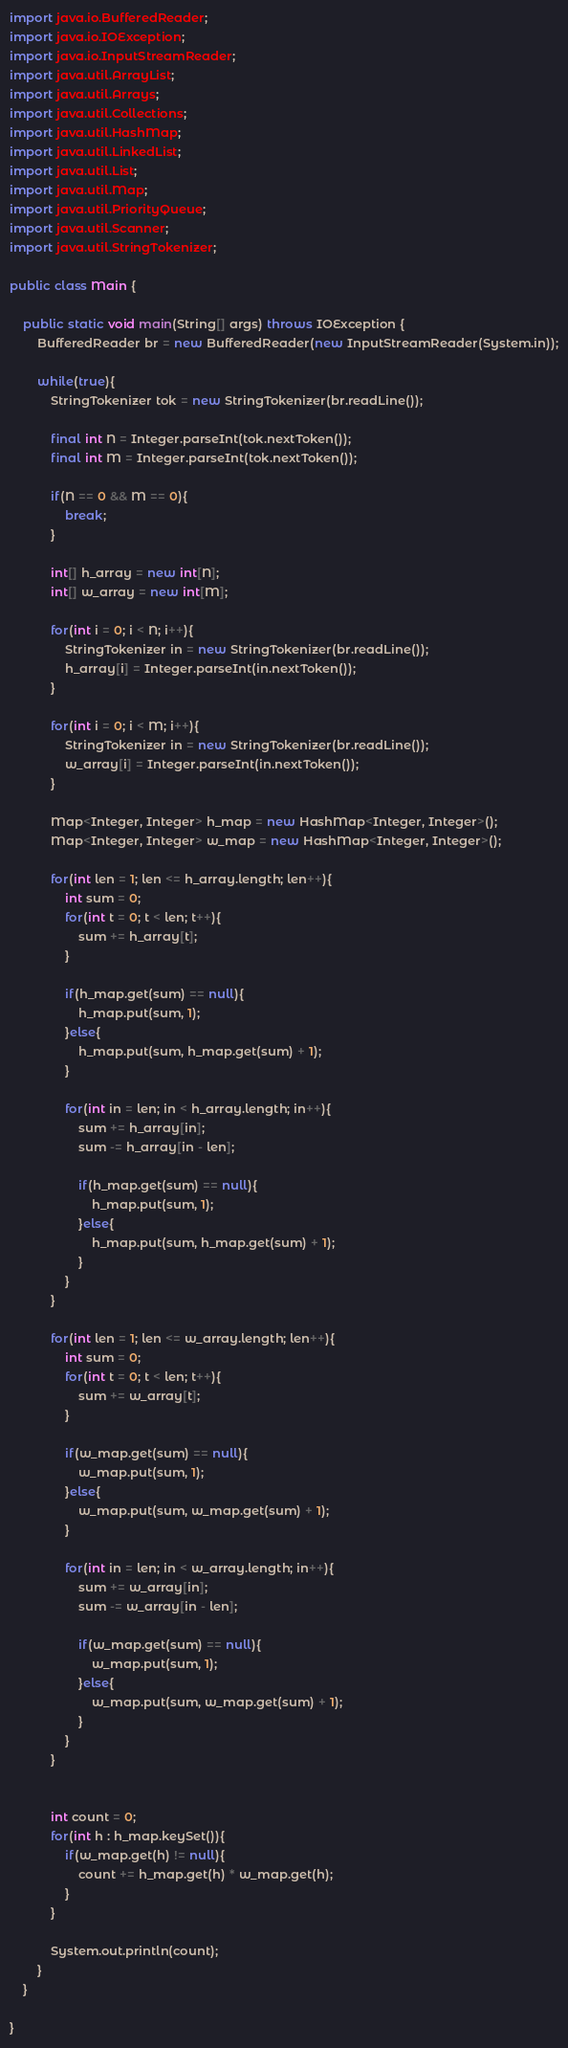Convert code to text. <code><loc_0><loc_0><loc_500><loc_500><_Java_>import java.io.BufferedReader;
import java.io.IOException;
import java.io.InputStreamReader;
import java.util.ArrayList;
import java.util.Arrays;
import java.util.Collections;
import java.util.HashMap;
import java.util.LinkedList;
import java.util.List;
import java.util.Map;
import java.util.PriorityQueue;
import java.util.Scanner;
import java.util.StringTokenizer;

public class Main {

	public static void main(String[] args) throws IOException {
		BufferedReader br = new BufferedReader(new InputStreamReader(System.in));

		while(true){
			StringTokenizer tok = new StringTokenizer(br.readLine());
			
			final int N = Integer.parseInt(tok.nextToken());
			final int M = Integer.parseInt(tok.nextToken());
			
			if(N == 0 && M == 0){
				break;
			}
			
			int[] h_array = new int[N];
			int[] w_array = new int[M];
			
			for(int i = 0; i < N; i++){
				StringTokenizer in = new StringTokenizer(br.readLine());
				h_array[i] = Integer.parseInt(in.nextToken());
			}
			
			for(int i = 0; i < M; i++){
				StringTokenizer in = new StringTokenizer(br.readLine());
				w_array[i] = Integer.parseInt(in.nextToken());
			}
			
			Map<Integer, Integer> h_map = new HashMap<Integer, Integer>();
			Map<Integer, Integer> w_map = new HashMap<Integer, Integer>();
			
			for(int len = 1; len <= h_array.length; len++){
				int sum = 0;
				for(int t = 0; t < len; t++){
					sum += h_array[t];
				}
				
				if(h_map.get(sum) == null){
					h_map.put(sum, 1);
				}else{
					h_map.put(sum, h_map.get(sum) + 1);
				}
				
				for(int in = len; in < h_array.length; in++){
					sum += h_array[in];
					sum -= h_array[in - len];
					
					if(h_map.get(sum) == null){
						h_map.put(sum, 1);
					}else{
						h_map.put(sum, h_map.get(sum) + 1);
					}
				}
			}
			
			for(int len = 1; len <= w_array.length; len++){
				int sum = 0;
				for(int t = 0; t < len; t++){
					sum += w_array[t];
				}
				
				if(w_map.get(sum) == null){
					w_map.put(sum, 1);
				}else{
					w_map.put(sum, w_map.get(sum) + 1);
				}
				
				for(int in = len; in < w_array.length; in++){
					sum += w_array[in];
					sum -= w_array[in - len];
					
					if(w_map.get(sum) == null){
						w_map.put(sum, 1);
					}else{
						w_map.put(sum, w_map.get(sum) + 1);
					}
				}
			}
			
			
			int count = 0;
			for(int h : h_map.keySet()){
				if(w_map.get(h) != null){
					count += h_map.get(h) * w_map.get(h);
				}
			}
			
			System.out.println(count);
		}
	}

}</code> 